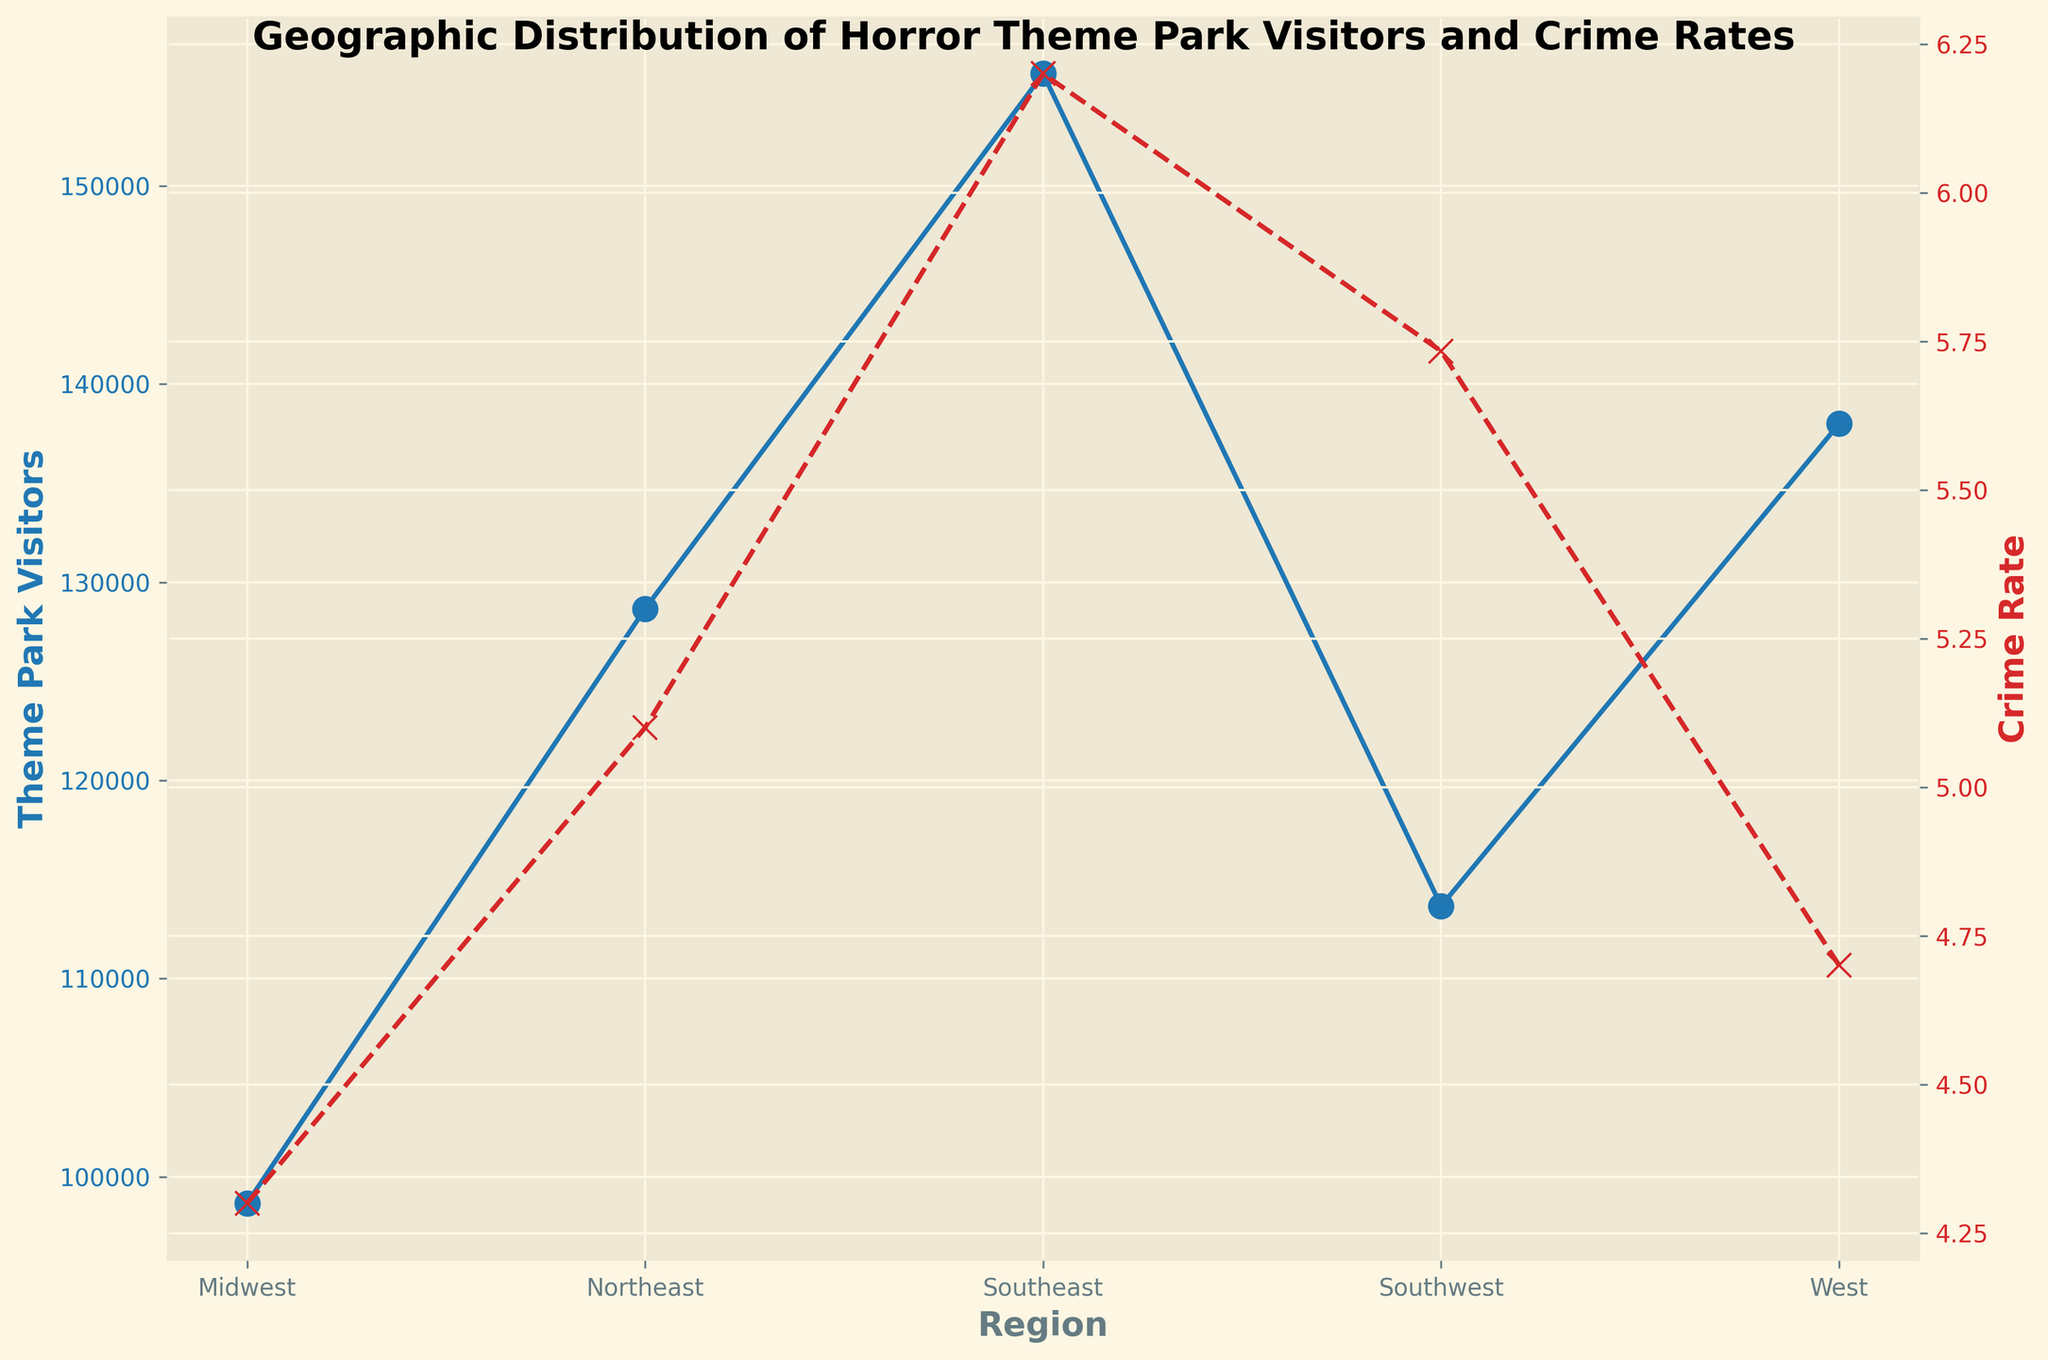Which region has the highest average number of horror theme park visitors? The line for theme park visitors plotted on the primary y-axis shows that the Southeast region has the highest average number of visitors.
Answer: Southeast Which region has the lowest average crime rate? The line for the crime rate plotted on the secondary y-axis indicates that the Midwest region has the lowest average crime rate.
Answer: Midwest What is the difference in the average number of theme park visitors between the Southeast and Midwest regions? From the plot, the Southeast region has an average of 157,000 visitors, while the Midwest has an average of 99,000 visitors. The difference is 157,000 - 99,000 = 58,000.
Answer: 58,000 By how much does the average crime rate in the Southeast region exceed that of the West region? The crime rate in the Southeast is 6.2, and in the West, it is 4.8. The difference is 6.2 - 4.8 = 1.4.
Answer: 1.4 Which region shows a closer alignment between the number of visitors and the crime rate based on the trends in the plot? Observing the trends, the Southwest region's lines for visitors and crime rate appear closely aligned, indicating a correlation between them.
Answer: Southwest What is the average crime rate across all regions? The average of the crime rates for each region is (5.1 + 4.3 + 6.2 + 5.7 + 4.8) / 5 = 5.22.
Answer: 5.22 Is there any region where the average crime rate is below the overall average crime rate of 5.22? The Midwest (4.3) and West (4.8) have crime rates below the overall average of 5.22.
Answer: Midwest and West Which region has a higher average number of visitors, the Northeast or the West? From the plot, the Northeast averages 128,666.67 visitors, whereas the West averages 138,000 visitors. Thus, the West has a higher average number of visitors.
Answer: West By how much does the difference in crime rates between the Southeast and Southwest compare to the difference in their visitor numbers? The Southeast has a crime rate of 6.2, and the Southwest is 5.7, so the difference is 0.5. Visitor numbers are 157,000 for Southeast and 113,000 for Southwest, the difference is 44,000.
Answer: Crime rate difference: 0.5, Visitor difference: 44,000 